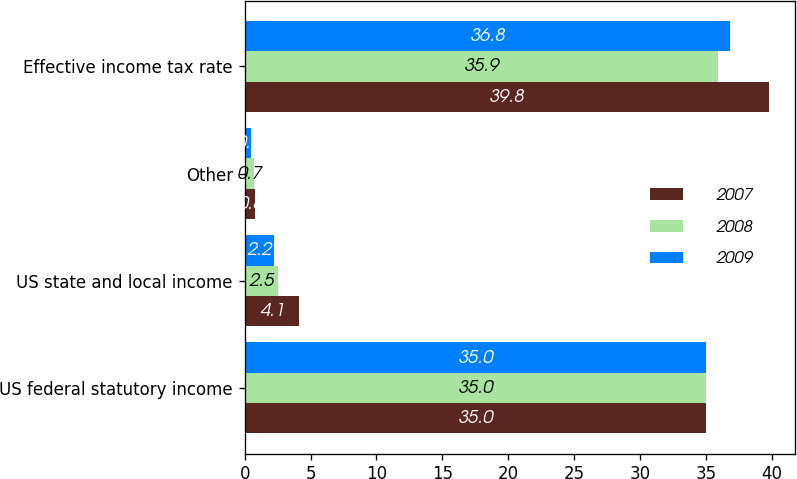Convert chart. <chart><loc_0><loc_0><loc_500><loc_500><stacked_bar_chart><ecel><fcel>US federal statutory income<fcel>US state and local income<fcel>Other<fcel>Effective income tax rate<nl><fcel>2007<fcel>35<fcel>4.1<fcel>0.8<fcel>39.8<nl><fcel>2008<fcel>35<fcel>2.5<fcel>0.7<fcel>35.9<nl><fcel>2009<fcel>35<fcel>2.2<fcel>0.5<fcel>36.8<nl></chart> 